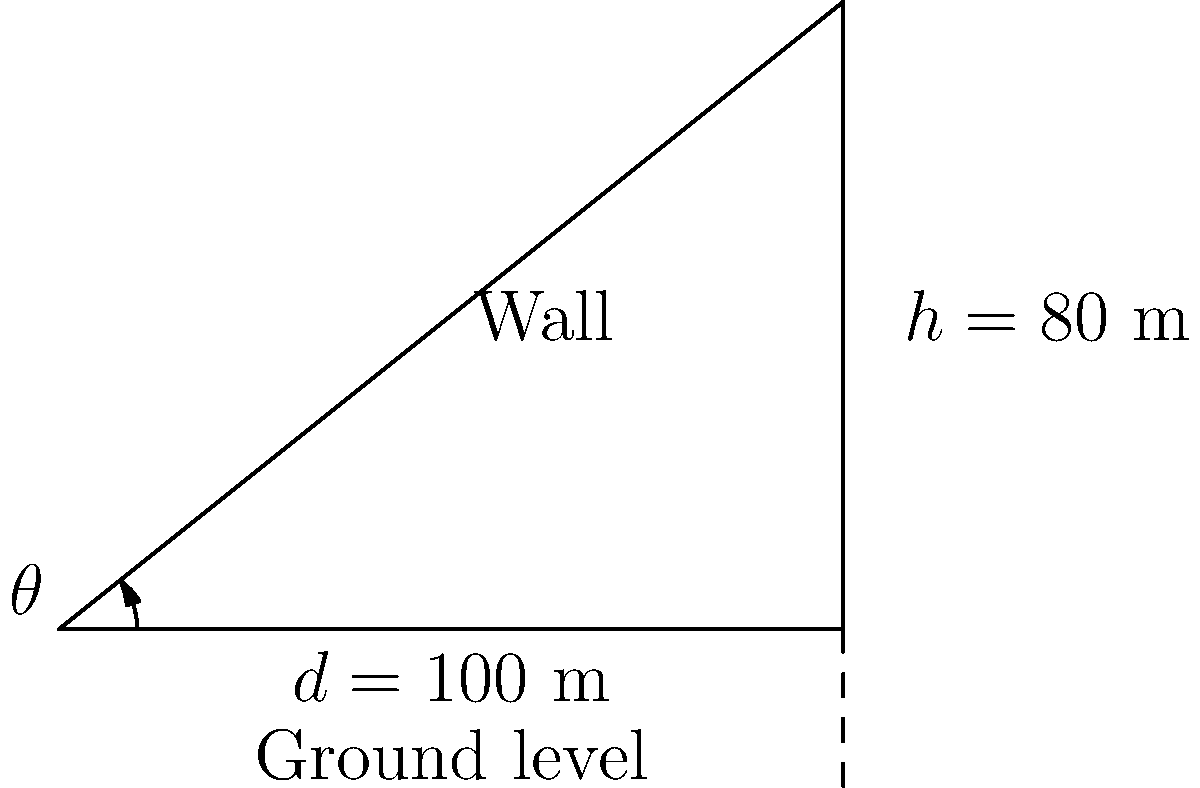At the Mehrangarh Fort in Jodhpur, Rajasthan, the sloped walls are a marvel of engineering. If the height of one such wall is 80 meters and it extends 100 meters horizontally from its base, what is the angle of inclination ($\theta$) of the wall with respect to the ground? To find the angle of inclination, we can use the trigonometric function tangent. Here's how:

1) In a right-angled triangle, $\tan \theta = \frac{\text{opposite}}{\text{adjacent}}$

2) In our case:
   - The opposite side is the height of the wall: $h = 80$ m
   - The adjacent side is the horizontal distance: $d = 100$ m

3) Therefore:
   $\tan \theta = \frac{80}{100} = 0.8$

4) To find $\theta$, we need to use the inverse tangent function (arctan or $\tan^{-1}$):
   $\theta = \tan^{-1}(0.8)$

5) Using a calculator or trigonometric tables:
   $\theta \approx 38.66°$

6) Rounding to the nearest degree:
   $\theta \approx 39°$
Answer: $39°$ 